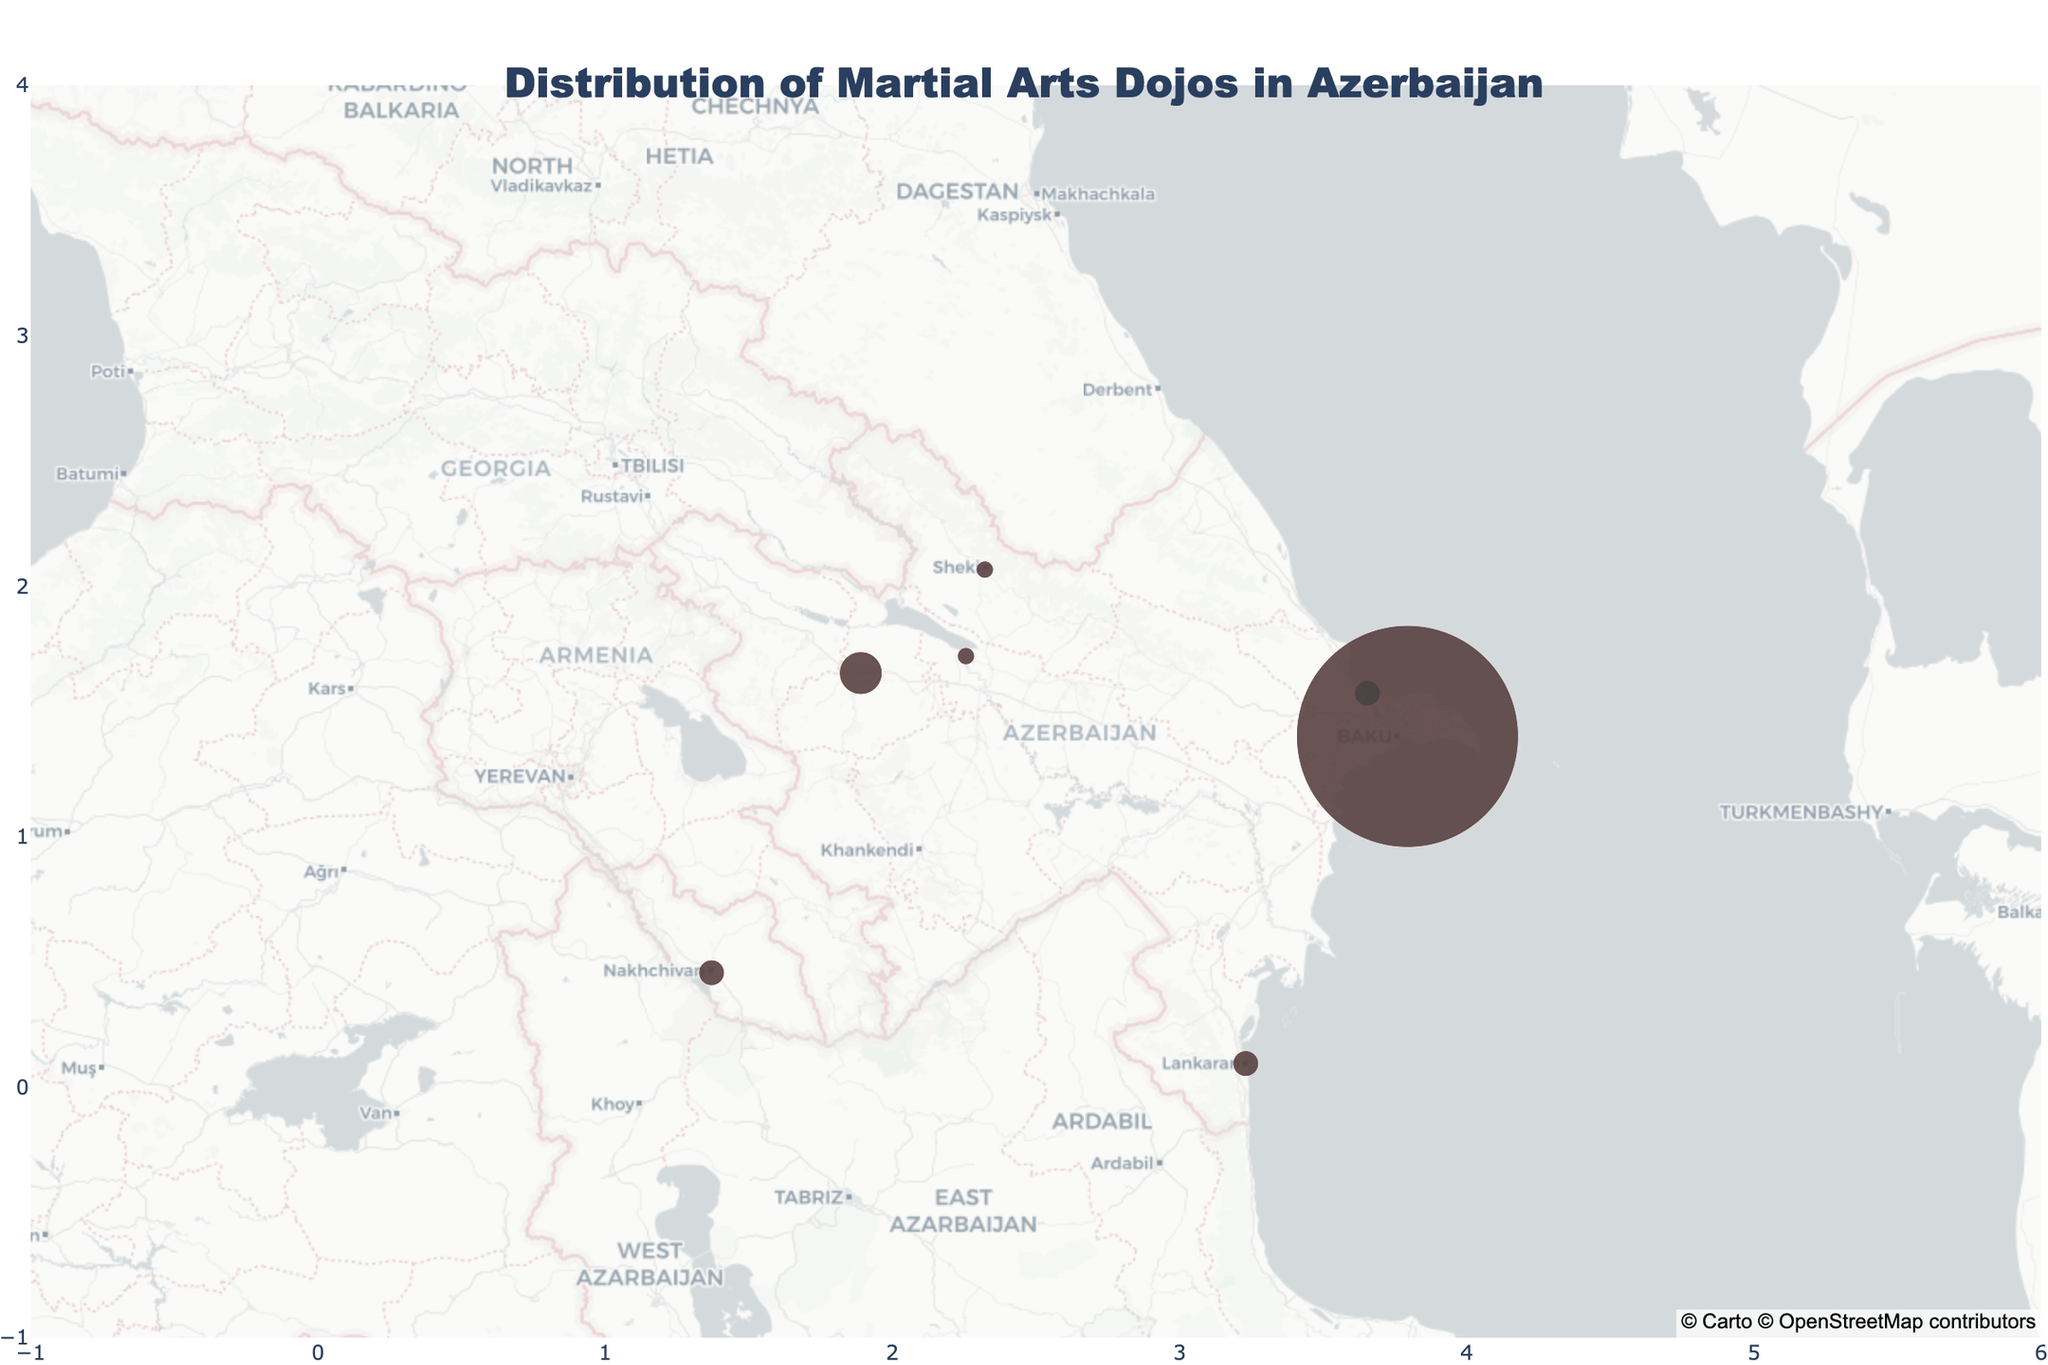What is the total number of dojos in Baku? The figure should show the total number of dojos in each city. Simply locate Baku on the map and sum the dojo counts for each style: 12 (Karate) + 8 (Judo) + 6 (Taekwondo).
Answer: 26 Which city has the highest number of Karate dojos? By examining the plotted data, we look for the city with the highest marker size and the respective style. Baku has 12 Karate dojos, the highest among all cities.
Answer: Baku How many martial arts styles are represented in Sumqayit, and which ones are they? Refer to the pie charts or itemized hover information to determine the styles. Sumqayit has Taekwondo (2 dojos) and Aikido (1 dojo).
Answer: 2 styles (Taekwondo, Aikido) Compare the number of Karate dojos in Ganja and Nakhchivan. Which city has more? From the data for Ganja (3 Karate dojos) and Nakhchivan (2 Karate dojos), compare the counts. Ganja has more.
Answer: Ganja Which city has the smallest total number of dojos, and how many are there? By checking each city's total dojo counts on the map, Mingachevir has the smallest with 2 dojos (Karate and Judo).
Answer: Mingachevir, 2 Are there any cities that have only one type of martial arts dojo? If so, which ones? Look for cities where the pie chart or hover information shows a single martial arts style. Mingachevir and Sheki each have only one type (Judo in Sheki, Karate in Mingachevir).
Answer: Mingachevir and Sheki What is the ratio of Judo dojos to Taekwondo dojos in Baku? In Baku, count the Judo dojos (8) and the Taekwondo dojos (6). Calculate the ratio 8/6. Simplified, it is 4:3.
Answer: 4:3 Which city has the second-highest number of total dojos after Baku, and how many dojos are there? After Baku, check and compare the total dojos for each city. Ganja has the second-highest with 5 dojos.
Answer: Ganja, 5 What is the average number of dojos per city in Azerbaijan? Sum the total dojo counts for all cities then divide by the number of cities. Total dojos: 38, number of cities: 7. Average = 38/7.
Answer: 5.43 